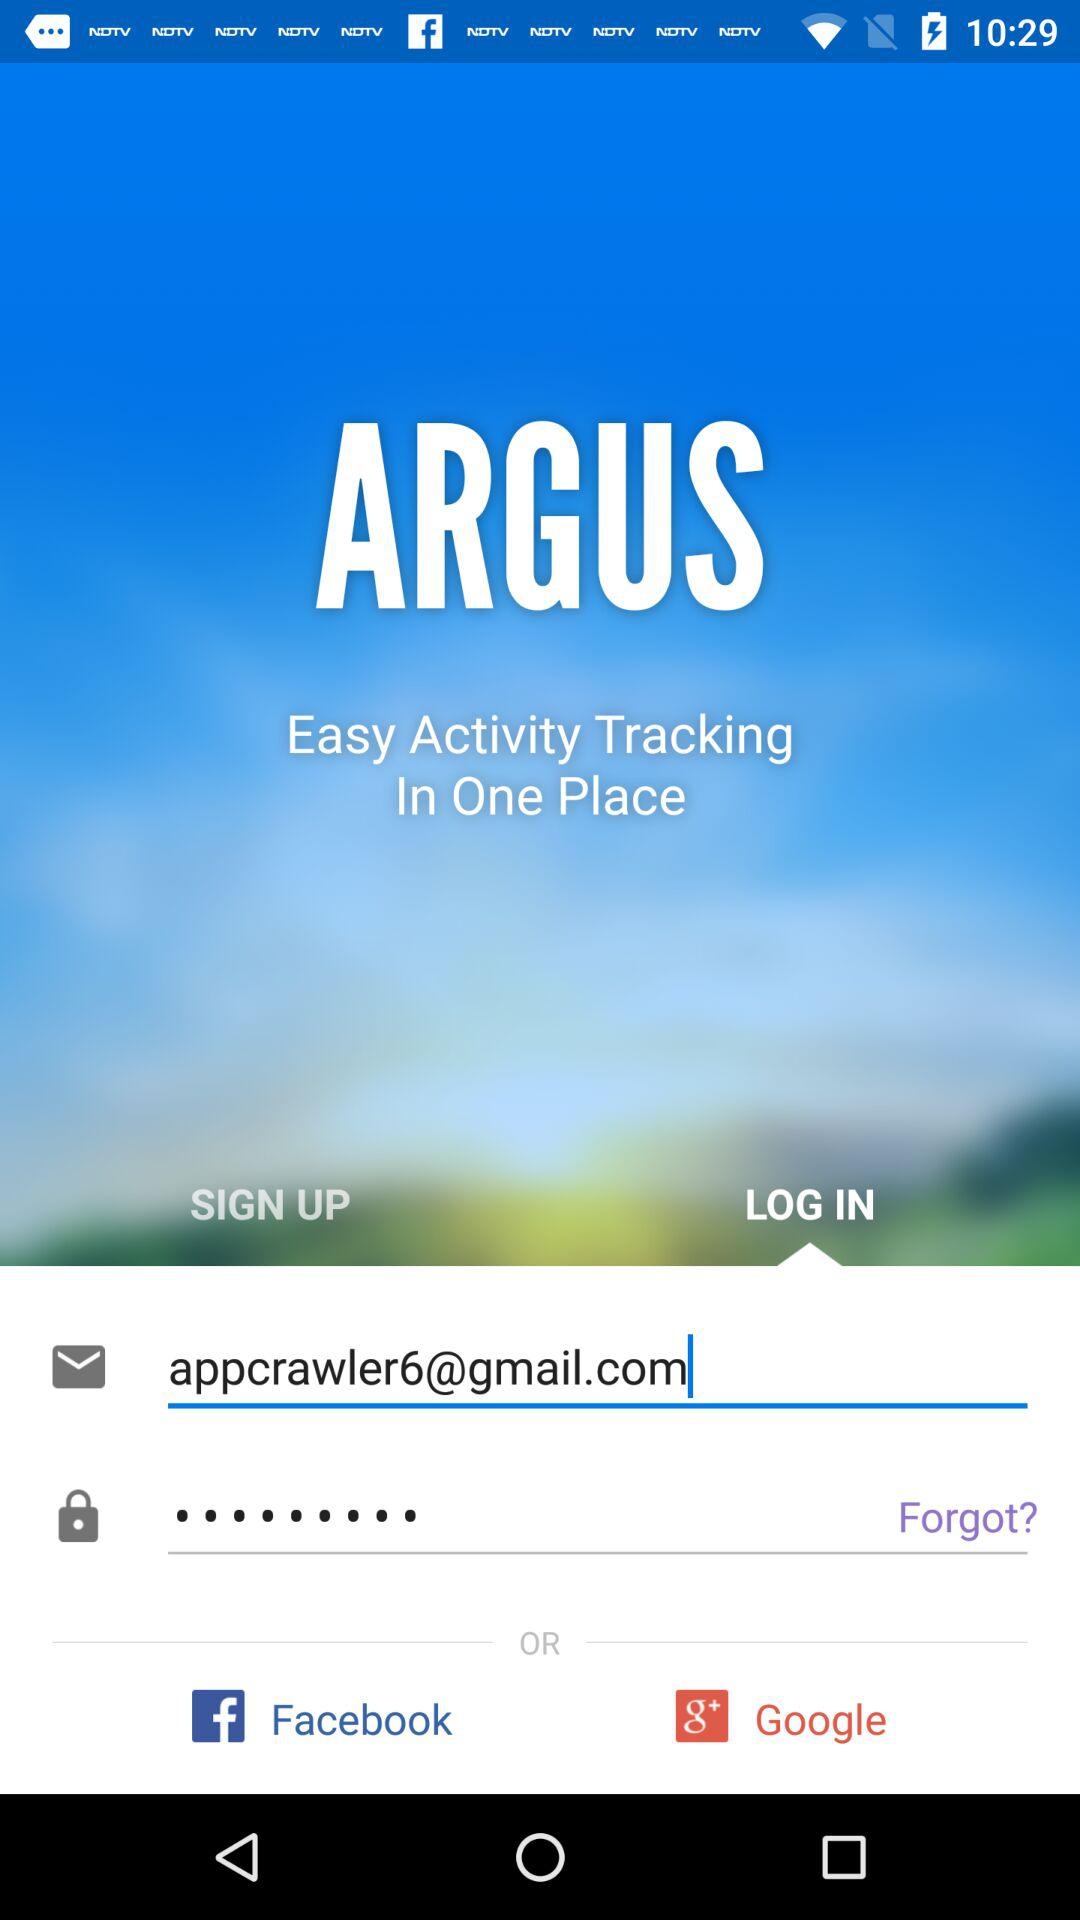Which tab has been selected? The selected tab is "LOG IN". 